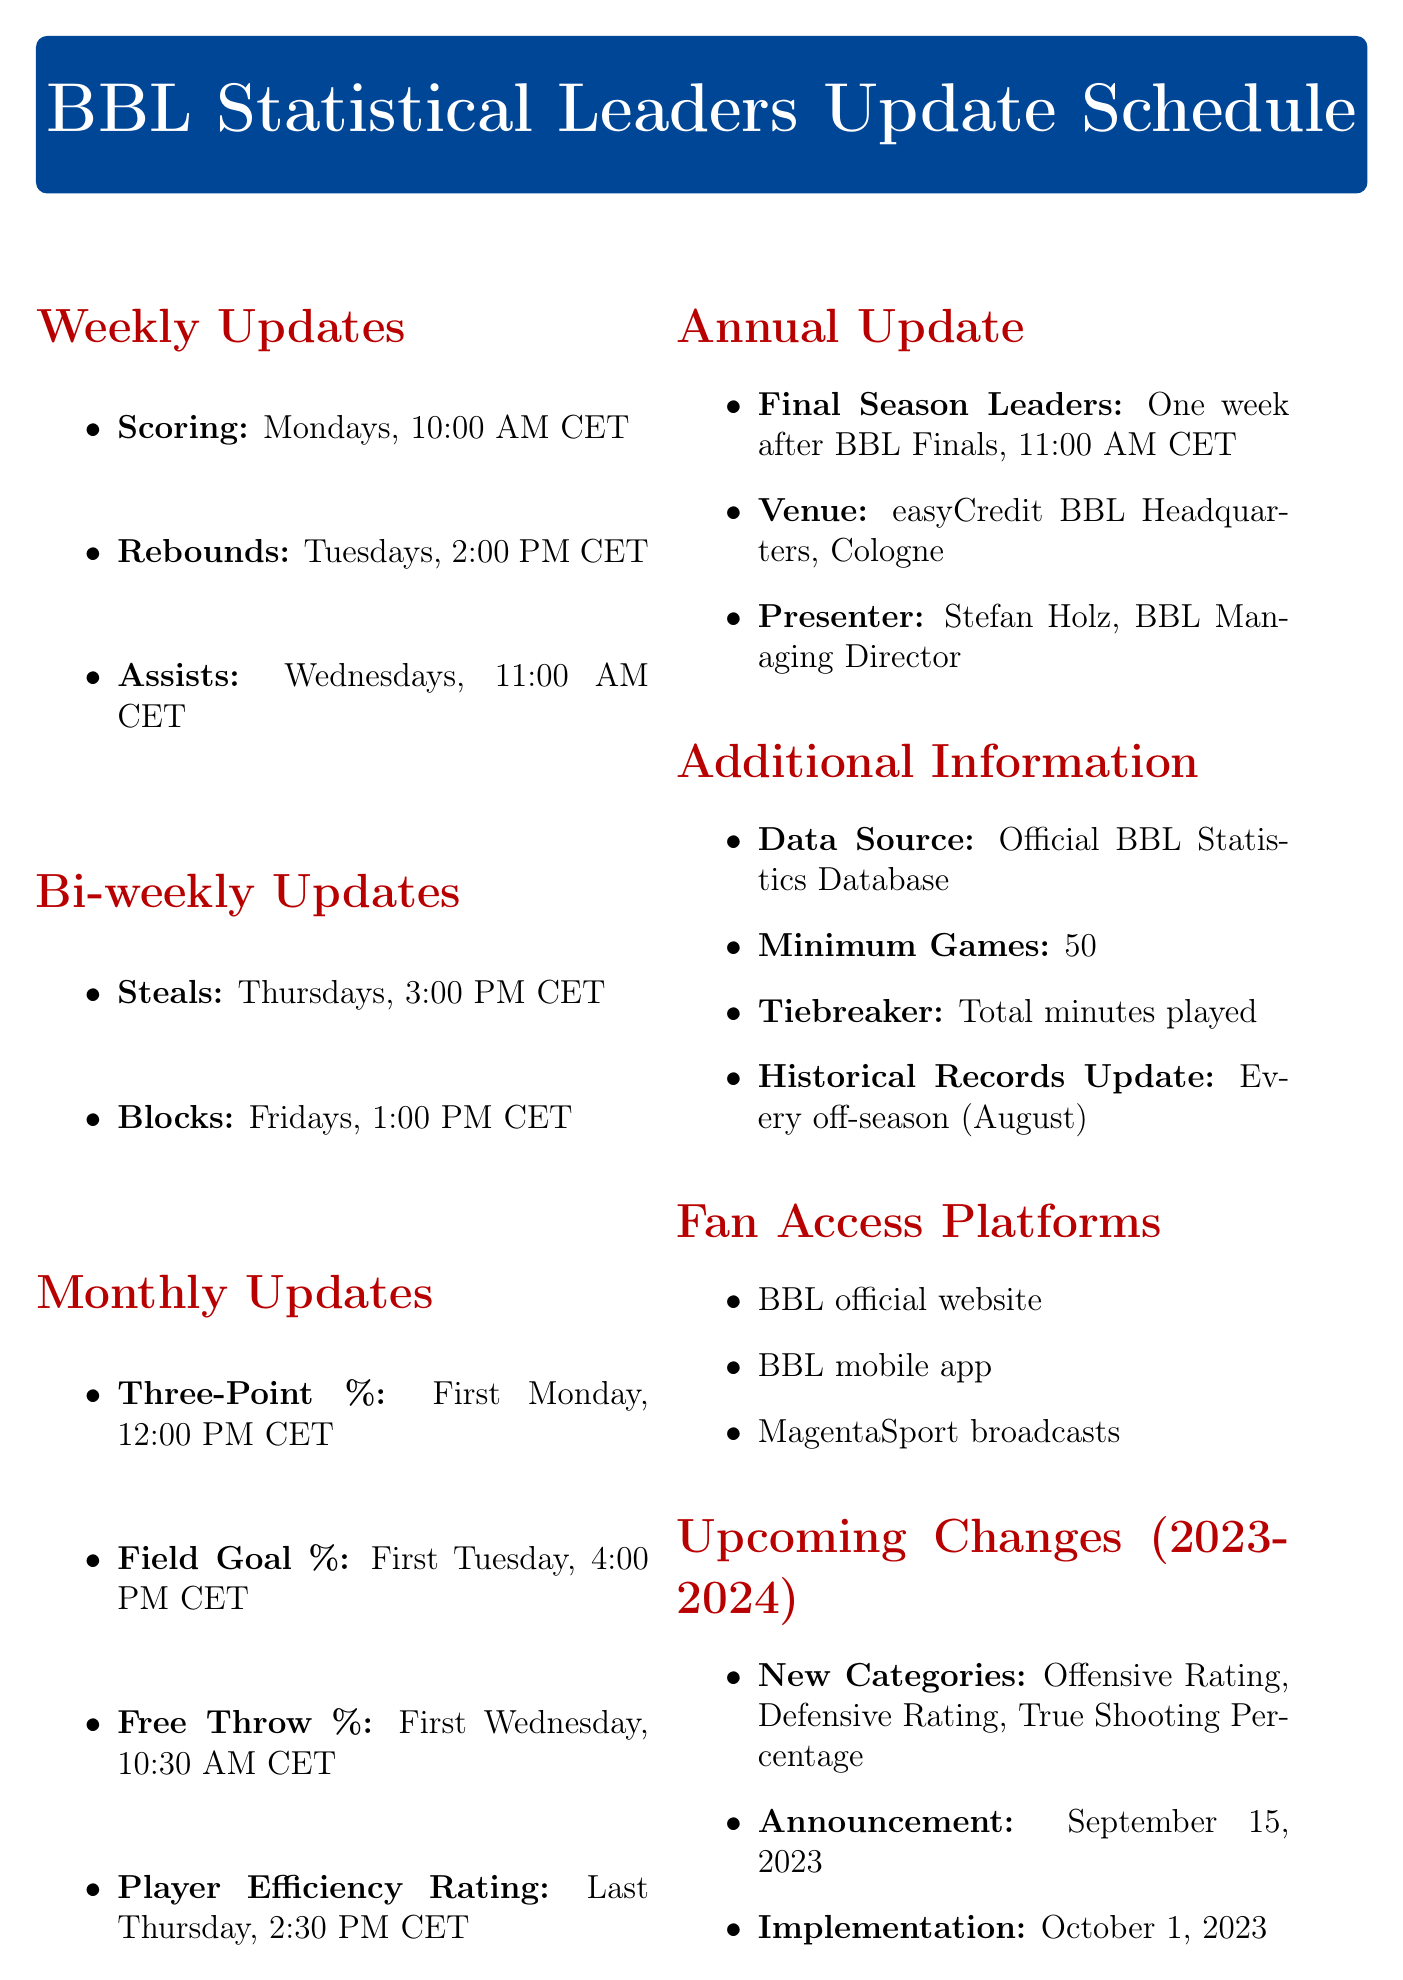What day of the week is the Scoring update? The Scoring update occurs every Monday as stated in the document under Weekly Updates.
Answer: Monday What time is the Rebounds update scheduled? The Rebounds update is scheduled for 2:00 PM CET on Tuesdays according to the Weekly Updates section of the document.
Answer: 2:00 PM CET How often are the Steals updates released? The document specifies that Steals updates are released bi-weekly, indicating an every-two-week schedule.
Answer: Bi-weekly Who presents the Final Season Leaders update? The Final Season Leaders update is presented by Stefan Holz, as mentioned in the Annual Update section of the document.
Answer: Stefan Holz What category update occurs on the first Wednesday? According to the Monthly Updates section, the Free Throw Percentage update occurs on the first Wednesday of the month.
Answer: Free Throw Percentage When are the new categories effective? The document states that the new categories will be implemented on October 1, 2023.
Answer: October 1, 2023 What is the minimum number of games played to qualify for the leaderboard? The document indicates that a player must have played a minimum of 50 games.
Answer: 50 Where do fans access the BBL stats updates? The document lists several platforms for fan access, including the BBL official website and mobile app.
Answer: BBL official website What is the frequency of Player Efficiency Rating updates? The document specifies that Player Efficiency Rating updates are released monthly, occurring on the last Thursday.
Answer: Monthly 